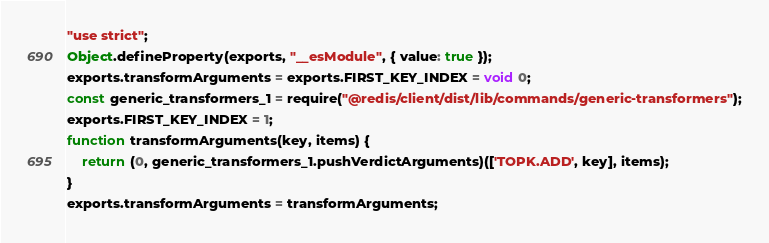<code> <loc_0><loc_0><loc_500><loc_500><_JavaScript_>"use strict";
Object.defineProperty(exports, "__esModule", { value: true });
exports.transformArguments = exports.FIRST_KEY_INDEX = void 0;
const generic_transformers_1 = require("@redis/client/dist/lib/commands/generic-transformers");
exports.FIRST_KEY_INDEX = 1;
function transformArguments(key, items) {
    return (0, generic_transformers_1.pushVerdictArguments)(['TOPK.ADD', key], items);
}
exports.transformArguments = transformArguments;
</code> 